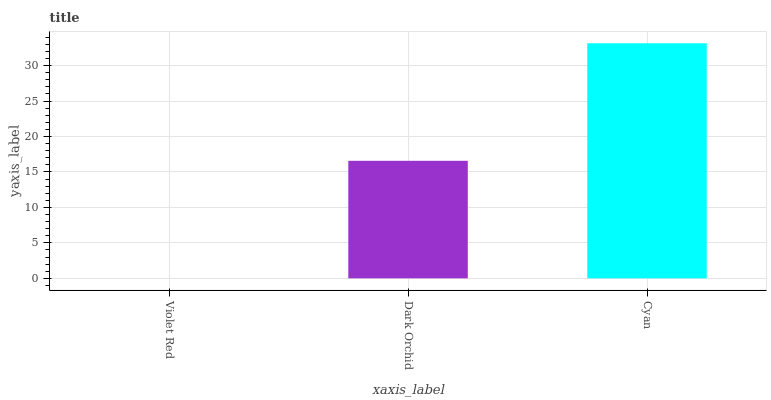Is Violet Red the minimum?
Answer yes or no. Yes. Is Cyan the maximum?
Answer yes or no. Yes. Is Dark Orchid the minimum?
Answer yes or no. No. Is Dark Orchid the maximum?
Answer yes or no. No. Is Dark Orchid greater than Violet Red?
Answer yes or no. Yes. Is Violet Red less than Dark Orchid?
Answer yes or no. Yes. Is Violet Red greater than Dark Orchid?
Answer yes or no. No. Is Dark Orchid less than Violet Red?
Answer yes or no. No. Is Dark Orchid the high median?
Answer yes or no. Yes. Is Dark Orchid the low median?
Answer yes or no. Yes. Is Violet Red the high median?
Answer yes or no. No. Is Violet Red the low median?
Answer yes or no. No. 